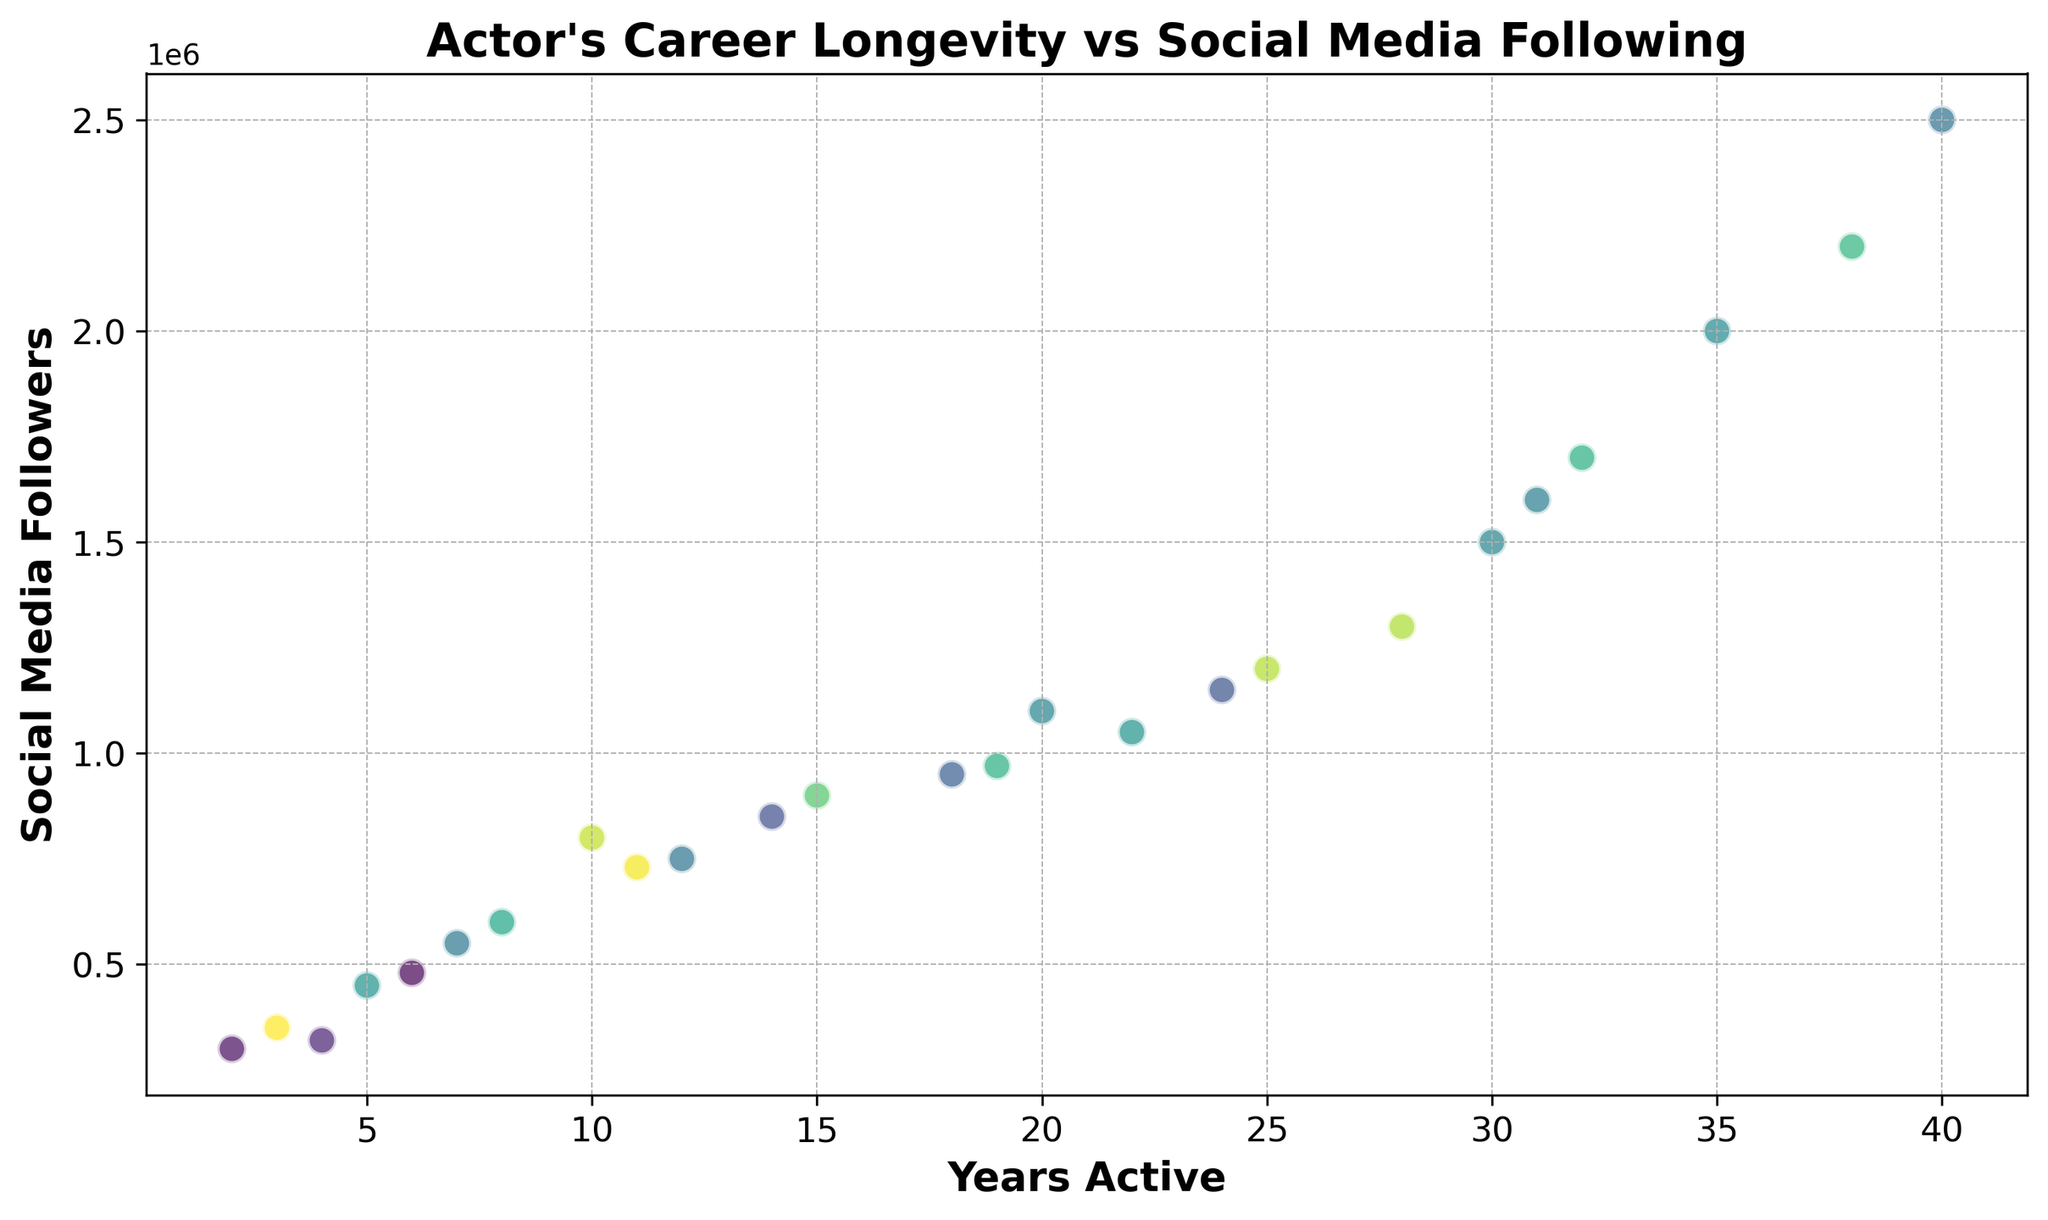What is the actor with the highest number of social media followers and how long have they been active? To determine this, locate the point with the highest y-value on the scatter plot. This point corresponds to the actor with the highest number of social media followers. Then, check the x-value for this point to find how many years the actor has been active.
Answer: Actor16, 40 years Which actor has been active for the shortest time yet has a significantly high number of social media followers? Identify the points on the scatter plot where the x-value is lowest, representing the shortest time active. Compare their y-values to determine which one has the highest number of social media followers.
Answer: Actor11, 2 years, 300000 followers What is the average number of social media followers for actors who have been active for more than 20 years? Identify the points where the x-value is greater than 20, sum their y-values (the number of followers), and divide by the number of such points to get the average. Points qualifying: Actor1, Actor4, Actor14, Actor15, Actor16, Actor20, Actor23, Actor25. Sum of y-values: 1200000, 1500000, 1300000, 1700000, 2500000, 1150000, 1600000, 2200000. Average = (1200000 + 1500000 + 1300000 + 1700000 + 2500000 + 1150000 + 1600000 + 2200000) / 8.
Answer: 1643750 followers Is there a correlation between the number of years active and social media followers for actors? Look for a visual pattern in the scatter plot; check if the y-values (followers) tend to increase or decrease as x-values (years active) increase. A pattern indicating correlation should be observable.
Answer: Yes, generally positive correlation Are there more actors with fewer than 10 years of experience or more? Count the number of points with x-values less than 10 and those with x-values greater than or equal to 10, then compare the counts. Points with less than 10 years: Actor3, Actor9, Actor11, Actor13, Actor17, Actor19, Actor24. Points with 10 or more years: Actor1, Actor2, Actor4, Actor5, Actor6, Actor7, Actor8, Actor10, Actor12, Actor14, Actor15, Actor16, Actor18, Actor20, Actor21, Actor22, Actor23, Actor25.
Answer: More actors with 10 or more years of experience 